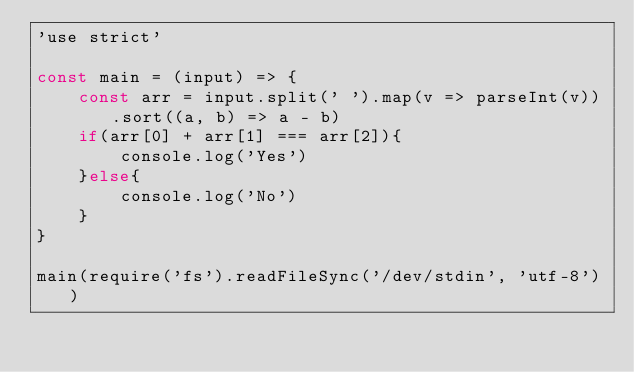<code> <loc_0><loc_0><loc_500><loc_500><_JavaScript_>'use strict'

const main = (input) => {
    const arr = input.split(' ').map(v => parseInt(v)).sort((a, b) => a - b)
    if(arr[0] + arr[1] === arr[2]){
        console.log('Yes')
    }else{
        console.log('No')
    }
}

main(require('fs').readFileSync('/dev/stdin', 'utf-8'))</code> 